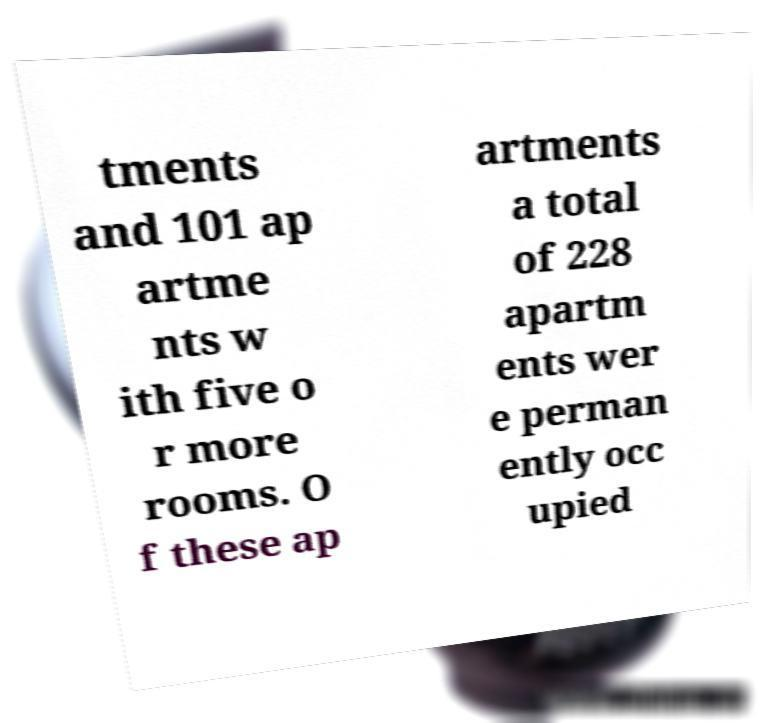There's text embedded in this image that I need extracted. Can you transcribe it verbatim? tments and 101 ap artme nts w ith five o r more rooms. O f these ap artments a total of 228 apartm ents wer e perman ently occ upied 